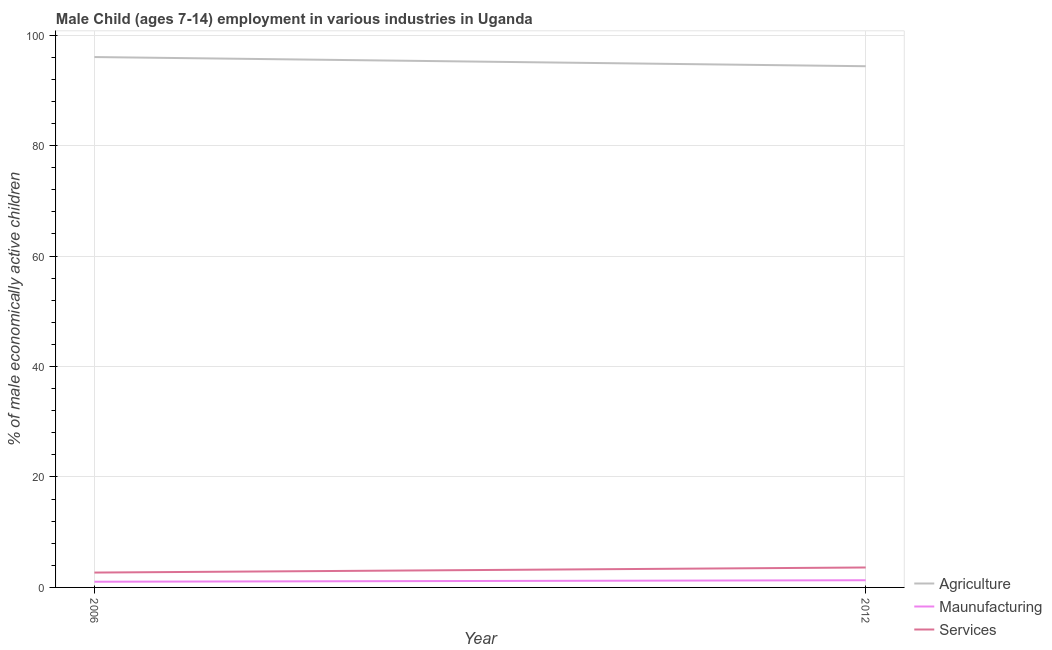What is the percentage of economically active children in manufacturing in 2006?
Ensure brevity in your answer.  1.03. Across all years, what is the maximum percentage of economically active children in manufacturing?
Your answer should be very brief. 1.3. Across all years, what is the minimum percentage of economically active children in services?
Offer a very short reply. 2.69. In which year was the percentage of economically active children in manufacturing maximum?
Provide a succinct answer. 2012. What is the difference between the percentage of economically active children in manufacturing in 2006 and that in 2012?
Your answer should be very brief. -0.27. What is the difference between the percentage of economically active children in manufacturing in 2012 and the percentage of economically active children in agriculture in 2006?
Offer a terse response. -94.72. What is the average percentage of economically active children in agriculture per year?
Make the answer very short. 95.19. In the year 2012, what is the difference between the percentage of economically active children in agriculture and percentage of economically active children in manufacturing?
Provide a succinct answer. 93.06. What is the ratio of the percentage of economically active children in manufacturing in 2006 to that in 2012?
Provide a short and direct response. 0.79. Is the percentage of economically active children in agriculture in 2006 less than that in 2012?
Give a very brief answer. No. In how many years, is the percentage of economically active children in manufacturing greater than the average percentage of economically active children in manufacturing taken over all years?
Your response must be concise. 1. Does the percentage of economically active children in agriculture monotonically increase over the years?
Give a very brief answer. No. How many years are there in the graph?
Give a very brief answer. 2. Does the graph contain grids?
Provide a succinct answer. Yes. How are the legend labels stacked?
Your answer should be very brief. Vertical. What is the title of the graph?
Provide a succinct answer. Male Child (ages 7-14) employment in various industries in Uganda. What is the label or title of the Y-axis?
Offer a very short reply. % of male economically active children. What is the % of male economically active children of Agriculture in 2006?
Make the answer very short. 96.02. What is the % of male economically active children in Services in 2006?
Your response must be concise. 2.69. What is the % of male economically active children in Agriculture in 2012?
Your answer should be compact. 94.36. What is the % of male economically active children in Maunufacturing in 2012?
Your answer should be very brief. 1.3. What is the % of male economically active children of Services in 2012?
Your response must be concise. 3.61. Across all years, what is the maximum % of male economically active children of Agriculture?
Your response must be concise. 96.02. Across all years, what is the maximum % of male economically active children of Services?
Make the answer very short. 3.61. Across all years, what is the minimum % of male economically active children of Agriculture?
Your response must be concise. 94.36. Across all years, what is the minimum % of male economically active children in Services?
Keep it short and to the point. 2.69. What is the total % of male economically active children of Agriculture in the graph?
Your answer should be compact. 190.38. What is the total % of male economically active children in Maunufacturing in the graph?
Ensure brevity in your answer.  2.33. What is the total % of male economically active children in Services in the graph?
Your answer should be very brief. 6.3. What is the difference between the % of male economically active children of Agriculture in 2006 and that in 2012?
Make the answer very short. 1.66. What is the difference between the % of male economically active children of Maunufacturing in 2006 and that in 2012?
Your answer should be very brief. -0.27. What is the difference between the % of male economically active children in Services in 2006 and that in 2012?
Make the answer very short. -0.92. What is the difference between the % of male economically active children in Agriculture in 2006 and the % of male economically active children in Maunufacturing in 2012?
Your answer should be very brief. 94.72. What is the difference between the % of male economically active children in Agriculture in 2006 and the % of male economically active children in Services in 2012?
Keep it short and to the point. 92.41. What is the difference between the % of male economically active children in Maunufacturing in 2006 and the % of male economically active children in Services in 2012?
Offer a very short reply. -2.58. What is the average % of male economically active children in Agriculture per year?
Give a very brief answer. 95.19. What is the average % of male economically active children in Maunufacturing per year?
Provide a short and direct response. 1.17. What is the average % of male economically active children of Services per year?
Provide a succinct answer. 3.15. In the year 2006, what is the difference between the % of male economically active children of Agriculture and % of male economically active children of Maunufacturing?
Your answer should be compact. 94.99. In the year 2006, what is the difference between the % of male economically active children in Agriculture and % of male economically active children in Services?
Ensure brevity in your answer.  93.33. In the year 2006, what is the difference between the % of male economically active children of Maunufacturing and % of male economically active children of Services?
Provide a short and direct response. -1.66. In the year 2012, what is the difference between the % of male economically active children in Agriculture and % of male economically active children in Maunufacturing?
Give a very brief answer. 93.06. In the year 2012, what is the difference between the % of male economically active children of Agriculture and % of male economically active children of Services?
Provide a short and direct response. 90.75. In the year 2012, what is the difference between the % of male economically active children of Maunufacturing and % of male economically active children of Services?
Offer a very short reply. -2.31. What is the ratio of the % of male economically active children in Agriculture in 2006 to that in 2012?
Keep it short and to the point. 1.02. What is the ratio of the % of male economically active children of Maunufacturing in 2006 to that in 2012?
Make the answer very short. 0.79. What is the ratio of the % of male economically active children in Services in 2006 to that in 2012?
Your response must be concise. 0.75. What is the difference between the highest and the second highest % of male economically active children of Agriculture?
Your response must be concise. 1.66. What is the difference between the highest and the second highest % of male economically active children in Maunufacturing?
Provide a short and direct response. 0.27. What is the difference between the highest and the lowest % of male economically active children of Agriculture?
Give a very brief answer. 1.66. What is the difference between the highest and the lowest % of male economically active children in Maunufacturing?
Provide a short and direct response. 0.27. 